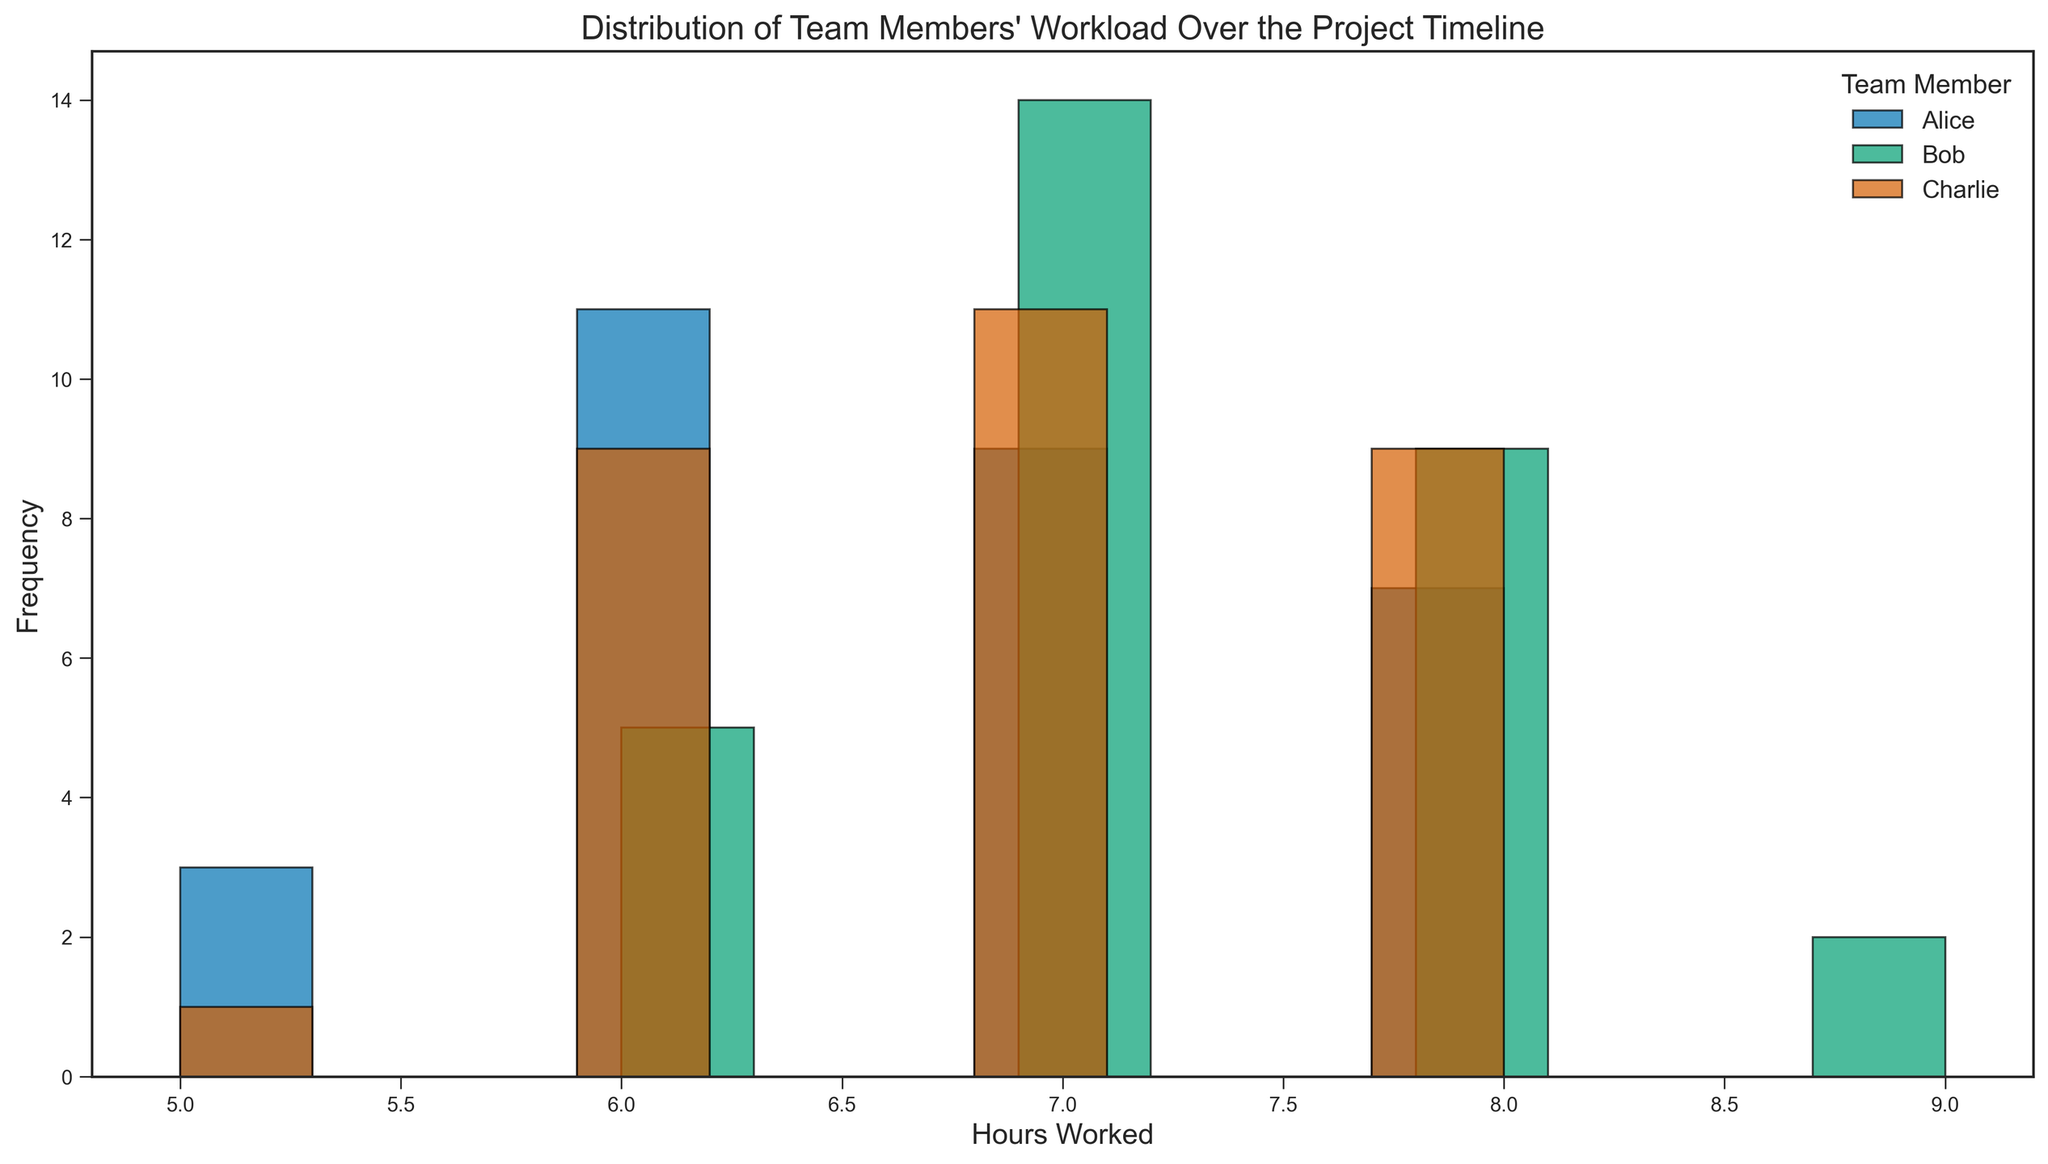What is the most frequent number of hours worked by Alice? To find the most frequent number of hours Alice worked, we look at the height of the bars in Alice's histogram and find the one with the highest frequency.
Answer: 7 Which team member has the widest range of hours worked? The range of hours worked for each team member can be seen by finding the difference between the highest and lowest values represented in their histogram. Charlie's histogram shows hours from 5 to 8, while Alice's and Bob's are similar. Thus, all members have the same range of hours worked, from 5 to 9 hours.
Answer: Alice, Bob, and Charlie (same range) Who worked 8 hours the most frequently? We need to compare the heights of the bars representing 8 hours worked for each team member. Bob's histogram has the most frequent occurrence with the highest bar at 8 hours.
Answer: Bob What is the average number of hours worked by Charlie? Refer to Charlie's histogram. The heights of the bars represent the frequency of each hour worked. Calculate the weighted average by multiplying hours by their frequency and then dividing by the total number of days worked.
Answer: 7 Did any team member work fewer than 6 hours in a day? Look at the leftmost bars of each histogram. Every bar represents the number of times hours were worked. Since there are no bars representing fewer than 6 hours in any histogram, no team member worked fewer than 6 hours.
Answer: No Which team member has the most consistent (least varied) workload? Consistency can be interpreted by looking for the histogram with the least spread between the bars and fewer different hours. Alice shows some variation, but Charlie's hours appear consistent over the middle range.
Answer: Charlie How many times did Bob work exactly 7 hours? Look at the bar labeled 7 in Bob's histogram. Count the frequency indicated by the bar's height. Bob worked 7 hours most frequently, appearing numerous times.
Answer: 10 times What are the peak work hours for each team member? Determine the hours corresponding to the highest bar in each member's histogram. Alice, Bob, and Charlie have noticeable peaks. The hour with the highest frequency for each gives the peak hour.
Answer: Alice: 7, Bob: 8, Charlie: 8 How does Bob's distribution of hours worked compare to Alice's? Compare the histograms for Bob and Alice by identifying patterns and differences in the bar heights and frequencies of hours worked. Bob has a peak at 8, whereas Alice's is generally more centered around 6 and 7 hours.
Answer: Bob's has a peak at 8, Alice's at 7 